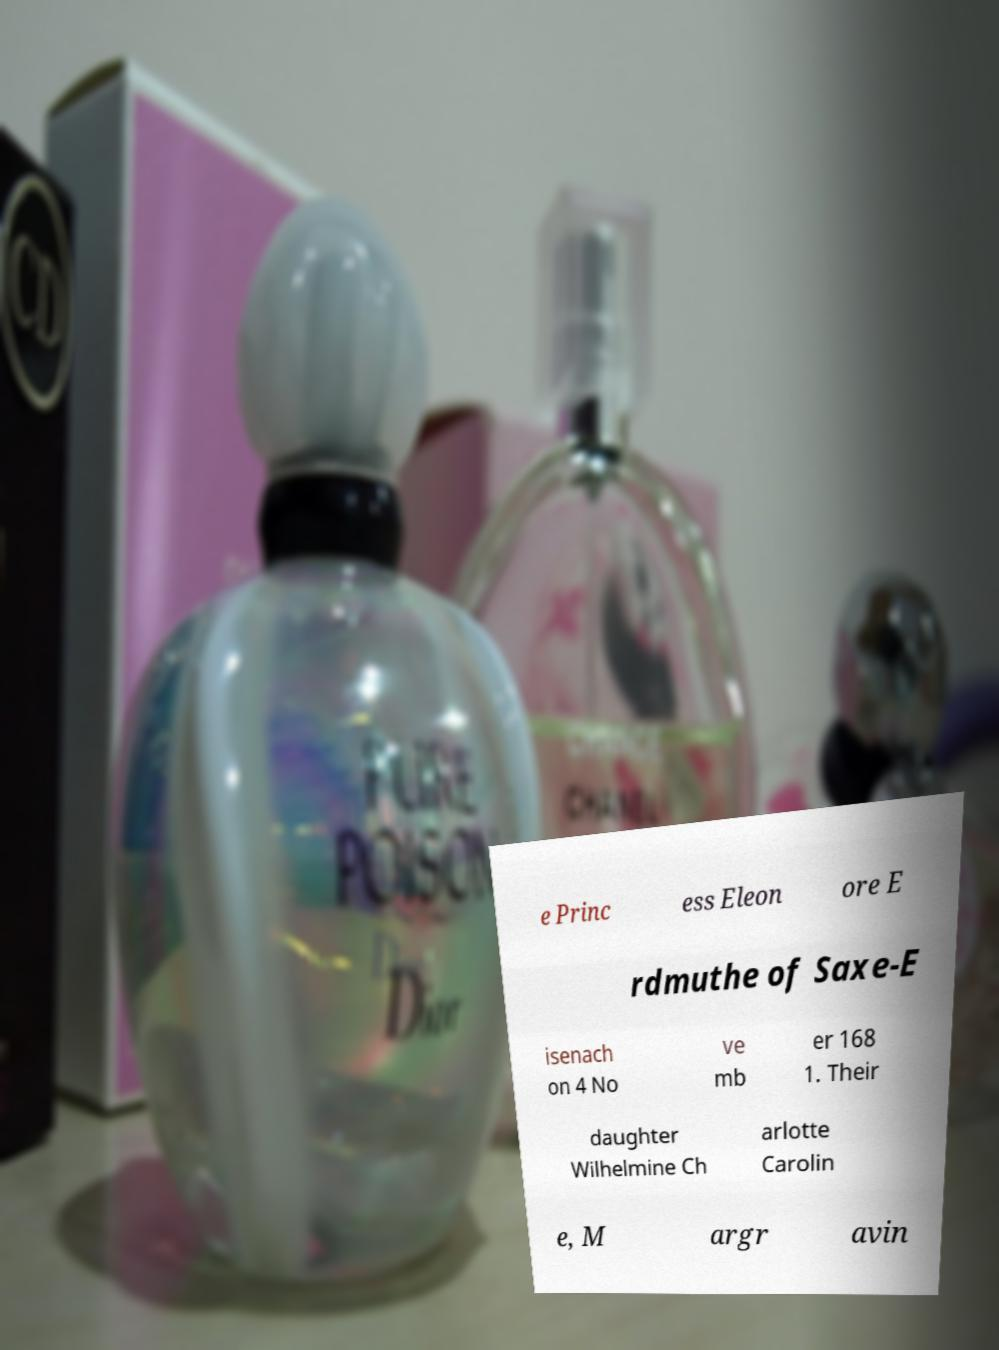For documentation purposes, I need the text within this image transcribed. Could you provide that? e Princ ess Eleon ore E rdmuthe of Saxe-E isenach on 4 No ve mb er 168 1. Their daughter Wilhelmine Ch arlotte Carolin e, M argr avin 